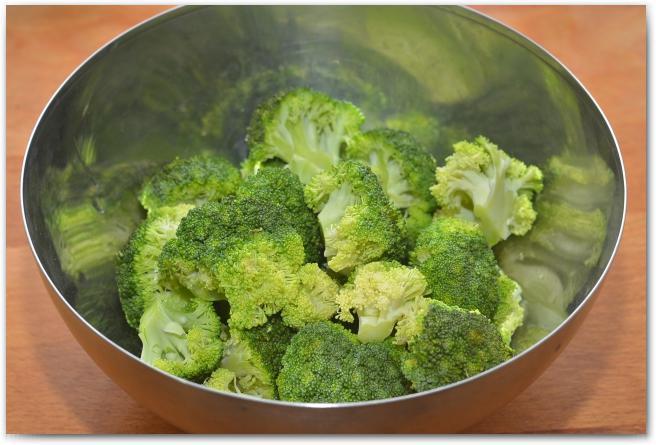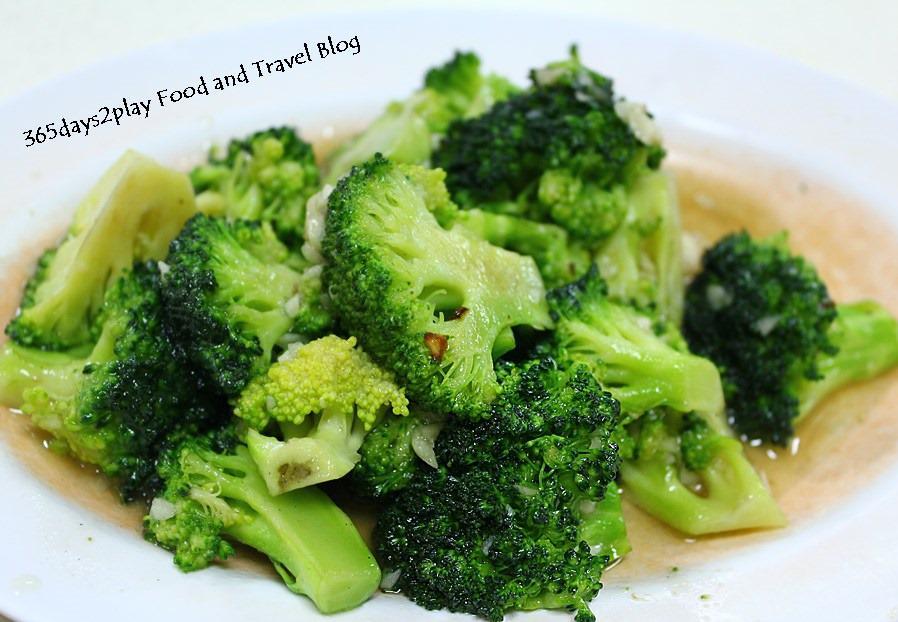The first image is the image on the left, the second image is the image on the right. Considering the images on both sides, is "One photo features a container made of metal." valid? Answer yes or no. Yes. The first image is the image on the left, the second image is the image on the right. Analyze the images presented: Is the assertion "Right image shows broccoli in a deep container with water." valid? Answer yes or no. No. 